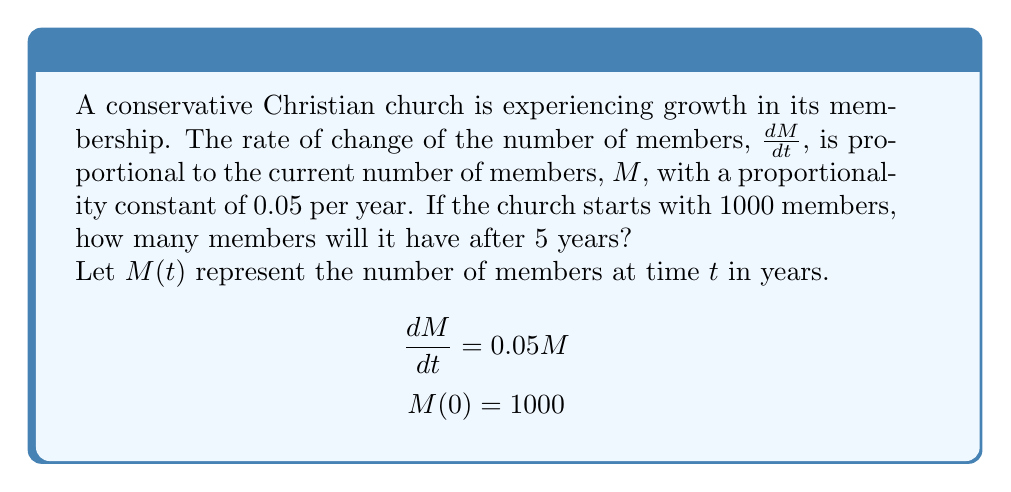Could you help me with this problem? To solve this first-order differential equation:

1) Rewrite the equation:
   $$\frac{dM}{M} = 0.05dt$$

2) Integrate both sides:
   $$\int \frac{dM}{M} = \int 0.05dt$$
   $$\ln|M| = 0.05t + C$$

3) Solve for $M$:
   $$M = e^{0.05t + C} = e^C \cdot e^{0.05t}$$
   Let $A = e^C$, then $M = A \cdot e^{0.05t}$

4) Use the initial condition $M(0) = 1000$ to find $A$:
   $$1000 = A \cdot e^{0.05 \cdot 0} = A$$

5) The general solution is:
   $$M(t) = 1000 \cdot e^{0.05t}$$

6) Calculate $M(5)$:
   $$M(5) = 1000 \cdot e^{0.05 \cdot 5} = 1000 \cdot e^{0.25} \approx 1284.02$$

Therefore, after 5 years, the church will have approximately 1284 members.
Answer: 1284 members 